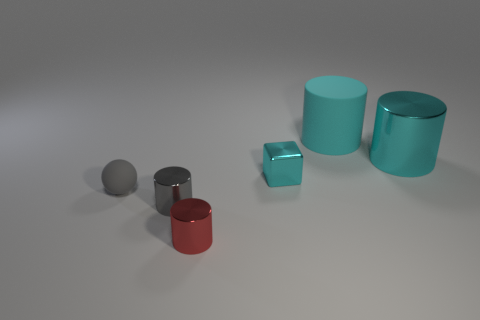What number of small objects are either cyan metal cubes or shiny cylinders? In the image, there is one cyan metal cube and two shiny metal cylinders, making for a total of three objects that match the description. 